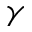<formula> <loc_0><loc_0><loc_500><loc_500>\gamma</formula> 